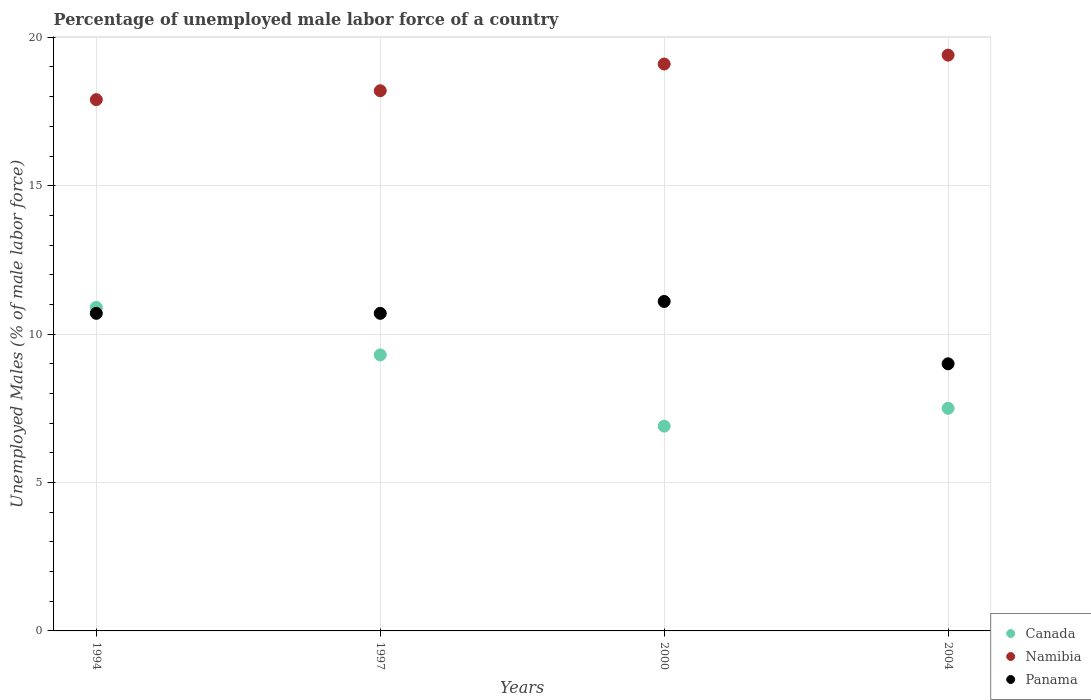How many different coloured dotlines are there?
Make the answer very short. 3. Is the number of dotlines equal to the number of legend labels?
Provide a short and direct response. Yes. What is the percentage of unemployed male labor force in Namibia in 1997?
Make the answer very short. 18.2. Across all years, what is the maximum percentage of unemployed male labor force in Panama?
Your response must be concise. 11.1. Across all years, what is the minimum percentage of unemployed male labor force in Namibia?
Offer a terse response. 17.9. In which year was the percentage of unemployed male labor force in Canada maximum?
Give a very brief answer. 1994. In which year was the percentage of unemployed male labor force in Canada minimum?
Provide a short and direct response. 2000. What is the total percentage of unemployed male labor force in Panama in the graph?
Offer a very short reply. 41.5. What is the difference between the percentage of unemployed male labor force in Canada in 1997 and that in 2000?
Give a very brief answer. 2.4. What is the difference between the percentage of unemployed male labor force in Namibia in 2004 and the percentage of unemployed male labor force in Canada in 2000?
Make the answer very short. 12.5. What is the average percentage of unemployed male labor force in Panama per year?
Provide a short and direct response. 10.37. In the year 1994, what is the difference between the percentage of unemployed male labor force in Panama and percentage of unemployed male labor force in Canada?
Make the answer very short. -0.2. In how many years, is the percentage of unemployed male labor force in Namibia greater than 9 %?
Make the answer very short. 4. What is the ratio of the percentage of unemployed male labor force in Canada in 1994 to that in 2004?
Your answer should be compact. 1.45. What is the difference between the highest and the second highest percentage of unemployed male labor force in Namibia?
Offer a terse response. 0.3. What is the difference between the highest and the lowest percentage of unemployed male labor force in Canada?
Provide a succinct answer. 4. In how many years, is the percentage of unemployed male labor force in Namibia greater than the average percentage of unemployed male labor force in Namibia taken over all years?
Provide a succinct answer. 2. Is it the case that in every year, the sum of the percentage of unemployed male labor force in Canada and percentage of unemployed male labor force in Namibia  is greater than the percentage of unemployed male labor force in Panama?
Offer a very short reply. Yes. Does the percentage of unemployed male labor force in Panama monotonically increase over the years?
Offer a very short reply. No. Is the percentage of unemployed male labor force in Namibia strictly greater than the percentage of unemployed male labor force in Canada over the years?
Your answer should be very brief. Yes. How many years are there in the graph?
Your answer should be very brief. 4. What is the difference between two consecutive major ticks on the Y-axis?
Give a very brief answer. 5. Are the values on the major ticks of Y-axis written in scientific E-notation?
Your answer should be compact. No. Does the graph contain any zero values?
Give a very brief answer. No. Does the graph contain grids?
Provide a succinct answer. Yes. Where does the legend appear in the graph?
Give a very brief answer. Bottom right. How many legend labels are there?
Provide a succinct answer. 3. How are the legend labels stacked?
Provide a short and direct response. Vertical. What is the title of the graph?
Offer a very short reply. Percentage of unemployed male labor force of a country. Does "Nigeria" appear as one of the legend labels in the graph?
Your answer should be very brief. No. What is the label or title of the X-axis?
Keep it short and to the point. Years. What is the label or title of the Y-axis?
Provide a succinct answer. Unemployed Males (% of male labor force). What is the Unemployed Males (% of male labor force) of Canada in 1994?
Offer a terse response. 10.9. What is the Unemployed Males (% of male labor force) in Namibia in 1994?
Keep it short and to the point. 17.9. What is the Unemployed Males (% of male labor force) in Panama in 1994?
Ensure brevity in your answer.  10.7. What is the Unemployed Males (% of male labor force) of Canada in 1997?
Provide a succinct answer. 9.3. What is the Unemployed Males (% of male labor force) of Namibia in 1997?
Your answer should be compact. 18.2. What is the Unemployed Males (% of male labor force) of Panama in 1997?
Provide a short and direct response. 10.7. What is the Unemployed Males (% of male labor force) in Canada in 2000?
Keep it short and to the point. 6.9. What is the Unemployed Males (% of male labor force) of Namibia in 2000?
Make the answer very short. 19.1. What is the Unemployed Males (% of male labor force) of Panama in 2000?
Offer a terse response. 11.1. What is the Unemployed Males (% of male labor force) of Namibia in 2004?
Keep it short and to the point. 19.4. Across all years, what is the maximum Unemployed Males (% of male labor force) in Canada?
Offer a terse response. 10.9. Across all years, what is the maximum Unemployed Males (% of male labor force) in Namibia?
Provide a succinct answer. 19.4. Across all years, what is the maximum Unemployed Males (% of male labor force) in Panama?
Make the answer very short. 11.1. Across all years, what is the minimum Unemployed Males (% of male labor force) in Canada?
Your answer should be compact. 6.9. Across all years, what is the minimum Unemployed Males (% of male labor force) of Namibia?
Ensure brevity in your answer.  17.9. What is the total Unemployed Males (% of male labor force) in Canada in the graph?
Keep it short and to the point. 34.6. What is the total Unemployed Males (% of male labor force) of Namibia in the graph?
Provide a short and direct response. 74.6. What is the total Unemployed Males (% of male labor force) in Panama in the graph?
Keep it short and to the point. 41.5. What is the difference between the Unemployed Males (% of male labor force) in Namibia in 1994 and that in 1997?
Ensure brevity in your answer.  -0.3. What is the difference between the Unemployed Males (% of male labor force) in Canada in 1994 and that in 2000?
Ensure brevity in your answer.  4. What is the difference between the Unemployed Males (% of male labor force) in Namibia in 1994 and that in 2000?
Make the answer very short. -1.2. What is the difference between the Unemployed Males (% of male labor force) in Panama in 1994 and that in 2000?
Ensure brevity in your answer.  -0.4. What is the difference between the Unemployed Males (% of male labor force) of Canada in 1994 and that in 2004?
Your answer should be compact. 3.4. What is the difference between the Unemployed Males (% of male labor force) of Canada in 1997 and that in 2000?
Offer a terse response. 2.4. What is the difference between the Unemployed Males (% of male labor force) of Namibia in 1997 and that in 2000?
Your answer should be very brief. -0.9. What is the difference between the Unemployed Males (% of male labor force) of Panama in 1997 and that in 2000?
Offer a terse response. -0.4. What is the difference between the Unemployed Males (% of male labor force) in Namibia in 2000 and that in 2004?
Give a very brief answer. -0.3. What is the difference between the Unemployed Males (% of male labor force) in Panama in 2000 and that in 2004?
Your answer should be very brief. 2.1. What is the difference between the Unemployed Males (% of male labor force) of Canada in 1994 and the Unemployed Males (% of male labor force) of Panama in 2000?
Give a very brief answer. -0.2. What is the difference between the Unemployed Males (% of male labor force) in Canada in 1994 and the Unemployed Males (% of male labor force) in Panama in 2004?
Your response must be concise. 1.9. What is the difference between the Unemployed Males (% of male labor force) in Canada in 1997 and the Unemployed Males (% of male labor force) in Namibia in 2000?
Your answer should be compact. -9.8. What is the difference between the Unemployed Males (% of male labor force) of Canada in 1997 and the Unemployed Males (% of male labor force) of Panama in 2000?
Your answer should be very brief. -1.8. What is the difference between the Unemployed Males (% of male labor force) in Canada in 1997 and the Unemployed Males (% of male labor force) in Namibia in 2004?
Your response must be concise. -10.1. What is the difference between the Unemployed Males (% of male labor force) of Canada in 2000 and the Unemployed Males (% of male labor force) of Panama in 2004?
Your answer should be very brief. -2.1. What is the average Unemployed Males (% of male labor force) in Canada per year?
Provide a short and direct response. 8.65. What is the average Unemployed Males (% of male labor force) in Namibia per year?
Keep it short and to the point. 18.65. What is the average Unemployed Males (% of male labor force) of Panama per year?
Keep it short and to the point. 10.38. In the year 1994, what is the difference between the Unemployed Males (% of male labor force) of Canada and Unemployed Males (% of male labor force) of Panama?
Provide a short and direct response. 0.2. In the year 1994, what is the difference between the Unemployed Males (% of male labor force) in Namibia and Unemployed Males (% of male labor force) in Panama?
Give a very brief answer. 7.2. In the year 1997, what is the difference between the Unemployed Males (% of male labor force) in Canada and Unemployed Males (% of male labor force) in Panama?
Ensure brevity in your answer.  -1.4. In the year 1997, what is the difference between the Unemployed Males (% of male labor force) of Namibia and Unemployed Males (% of male labor force) of Panama?
Make the answer very short. 7.5. In the year 2000, what is the difference between the Unemployed Males (% of male labor force) in Canada and Unemployed Males (% of male labor force) in Namibia?
Your answer should be compact. -12.2. In the year 2000, what is the difference between the Unemployed Males (% of male labor force) in Canada and Unemployed Males (% of male labor force) in Panama?
Make the answer very short. -4.2. In the year 2004, what is the difference between the Unemployed Males (% of male labor force) in Canada and Unemployed Males (% of male labor force) in Namibia?
Provide a short and direct response. -11.9. In the year 2004, what is the difference between the Unemployed Males (% of male labor force) in Canada and Unemployed Males (% of male labor force) in Panama?
Keep it short and to the point. -1.5. In the year 2004, what is the difference between the Unemployed Males (% of male labor force) in Namibia and Unemployed Males (% of male labor force) in Panama?
Your answer should be compact. 10.4. What is the ratio of the Unemployed Males (% of male labor force) in Canada in 1994 to that in 1997?
Offer a terse response. 1.17. What is the ratio of the Unemployed Males (% of male labor force) in Namibia in 1994 to that in 1997?
Make the answer very short. 0.98. What is the ratio of the Unemployed Males (% of male labor force) of Canada in 1994 to that in 2000?
Ensure brevity in your answer.  1.58. What is the ratio of the Unemployed Males (% of male labor force) in Namibia in 1994 to that in 2000?
Give a very brief answer. 0.94. What is the ratio of the Unemployed Males (% of male labor force) in Panama in 1994 to that in 2000?
Offer a terse response. 0.96. What is the ratio of the Unemployed Males (% of male labor force) in Canada in 1994 to that in 2004?
Your response must be concise. 1.45. What is the ratio of the Unemployed Males (% of male labor force) of Namibia in 1994 to that in 2004?
Offer a terse response. 0.92. What is the ratio of the Unemployed Males (% of male labor force) in Panama in 1994 to that in 2004?
Give a very brief answer. 1.19. What is the ratio of the Unemployed Males (% of male labor force) in Canada in 1997 to that in 2000?
Provide a short and direct response. 1.35. What is the ratio of the Unemployed Males (% of male labor force) in Namibia in 1997 to that in 2000?
Make the answer very short. 0.95. What is the ratio of the Unemployed Males (% of male labor force) of Panama in 1997 to that in 2000?
Keep it short and to the point. 0.96. What is the ratio of the Unemployed Males (% of male labor force) of Canada in 1997 to that in 2004?
Ensure brevity in your answer.  1.24. What is the ratio of the Unemployed Males (% of male labor force) in Namibia in 1997 to that in 2004?
Your answer should be very brief. 0.94. What is the ratio of the Unemployed Males (% of male labor force) in Panama in 1997 to that in 2004?
Ensure brevity in your answer.  1.19. What is the ratio of the Unemployed Males (% of male labor force) of Namibia in 2000 to that in 2004?
Keep it short and to the point. 0.98. What is the ratio of the Unemployed Males (% of male labor force) in Panama in 2000 to that in 2004?
Your response must be concise. 1.23. What is the difference between the highest and the second highest Unemployed Males (% of male labor force) in Namibia?
Provide a succinct answer. 0.3. What is the difference between the highest and the second highest Unemployed Males (% of male labor force) in Panama?
Provide a short and direct response. 0.4. What is the difference between the highest and the lowest Unemployed Males (% of male labor force) in Canada?
Your answer should be compact. 4. What is the difference between the highest and the lowest Unemployed Males (% of male labor force) in Panama?
Provide a succinct answer. 2.1. 